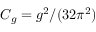Convert formula to latex. <formula><loc_0><loc_0><loc_500><loc_500>C _ { g } = g ^ { 2 } / ( 3 2 \pi ^ { 2 } )</formula> 